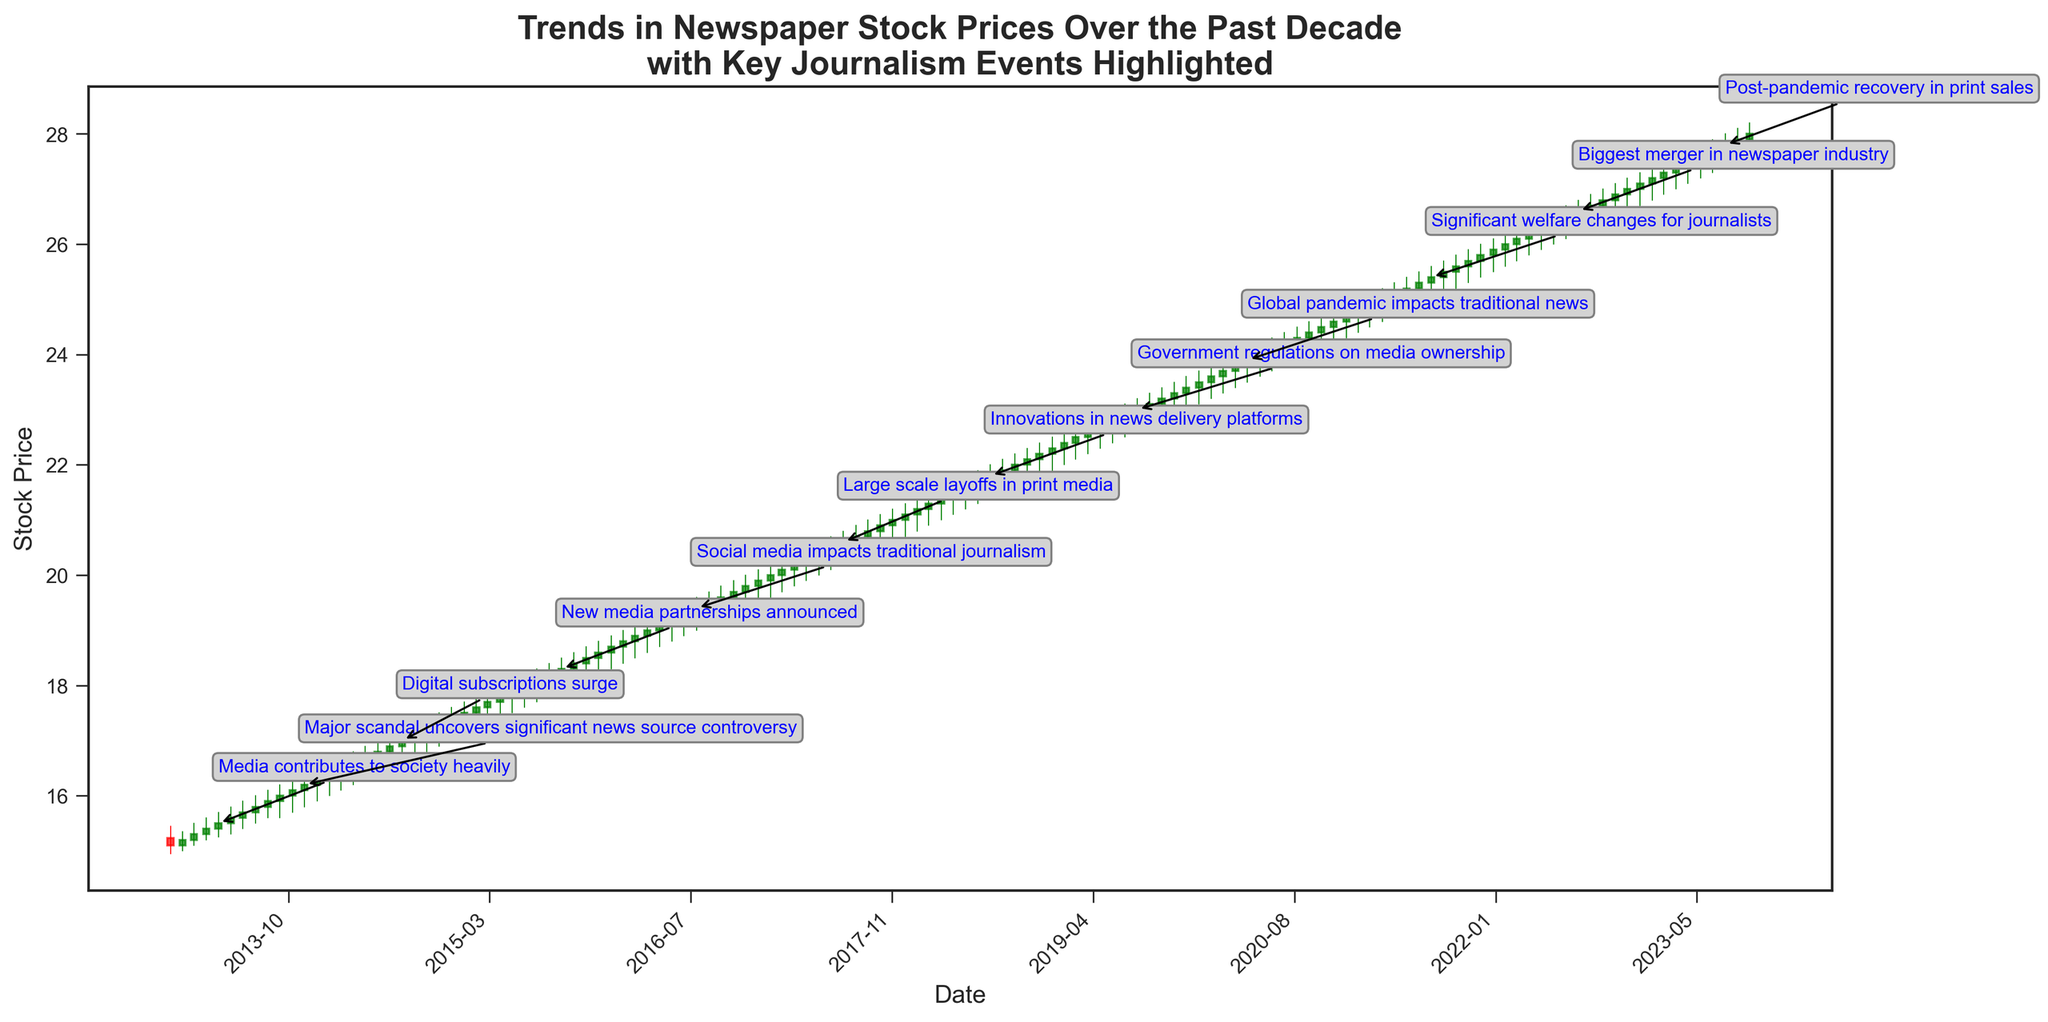When was the first event "Media contributes to society heavily," and what was the stock's closing price then? Locate the “Media contributes to society heavily” annotation on the figure, find the corresponding date in the x-axis, and read the closing price at that point.
Answer: May 2013, 15.50 What is the average closing price in 2019? Identify the closing prices for each month in 2019, sum them up, and divide by the number of months. The closing prices are 22.30, 22.40, 22.50, 22.60, 22.70, 22.80, 22.90, 23.00, 23.10, 23.20, 23.30, and 23.40 respectively. The sum is 273.2, so the average is 273.2/12.
Answer: 22.77 How did the stock price react to the event "Government regulations on media ownership"? Locate the “Government regulations on media ownership” annotation. Compare the closing prices immediately before and after the event. The stock closes at 22.80 right after the event and previously at 22.60.
Answer: The price increased Which event corresponds with the highest stock volume and what was that volume? Check the annotations and identify the volume associated with each. The "Post-pandemic recovery in print sales" event in August 2023 coincides with the highest volume of 820,000.
Answer: Post-pandemic recovery in print sales, 820,000 Compare the stock level changes before and after the digital subscriptions surged. Look at the "Digital subscriptions surge" annotation. Identify the closing prices before (July 2014: 16.90) and after (September 2014: 17.10). Calculate the difference.
Answer: The stock increased by 0.20 Which event marked the largest increase in the stock price within the same year and what was the increase? Look at the annotations and compare the stock prices before and after each event within the same year. "Major scandal uncovers significant news source controversy" in 2013 shows an increase from 16.20 to 16.30. No larger increases within the same year are annotated.
Answer: Major scandal uncovers significant news source controversy, 0.10 What trend in stock prices is seen after the "Global pandemic impacts traditional news" event? Identify the date of the event in May 2020 and observe the stock prices in the months following. The stock prices continue to rise steadily after the event.
Answer: The prices increased steadily What month and year did the stock first close above 25 dollars and what event happened around that time? Track the closing prices and locate the point where it first surpassed 25 dollars. In April 2021, the closing price moved above 25. Shortly before this in December 2020, there was no specific event noted.
Answer: April 2021, No specific event Compare the stock variations between the beginning (2013) and the end (2023) periods. Look at the starting price in January 2013 (15.10) and finishing price in October 2023 (28.00). The stock has significantly appreciated.
Answer: The stock price increased from 15.10 to 28.00 